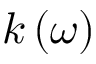<formula> <loc_0><loc_0><loc_500><loc_500>k \left ( \omega \right )</formula> 